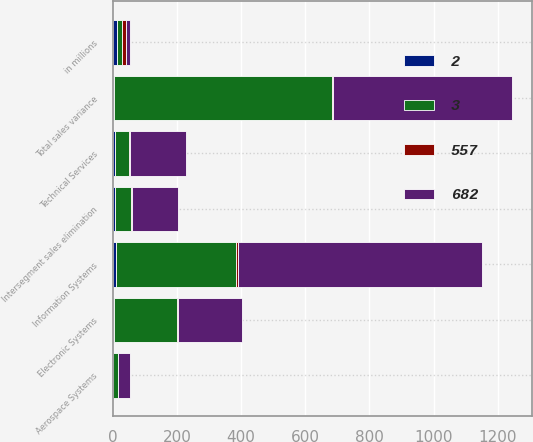<chart> <loc_0><loc_0><loc_500><loc_500><stacked_bar_chart><ecel><fcel>in millions<fcel>Aerospace Systems<fcel>Electronic Systems<fcel>Information Systems<fcel>Technical Services<fcel>Intersegment sales elimination<fcel>Total sales variance<nl><fcel>3<fcel>13.5<fcel>17<fcel>198<fcel>374<fcel>44<fcel>49<fcel>682<nl><fcel>557<fcel>13.5<fcel>0<fcel>3<fcel>6<fcel>2<fcel>3<fcel>3<nl><fcel>682<fcel>13.5<fcel>37<fcel>199<fcel>760<fcel>176<fcel>143<fcel>557<nl><fcel>2<fcel>13.5<fcel>0<fcel>3<fcel>10<fcel>6<fcel>7<fcel>2<nl></chart> 